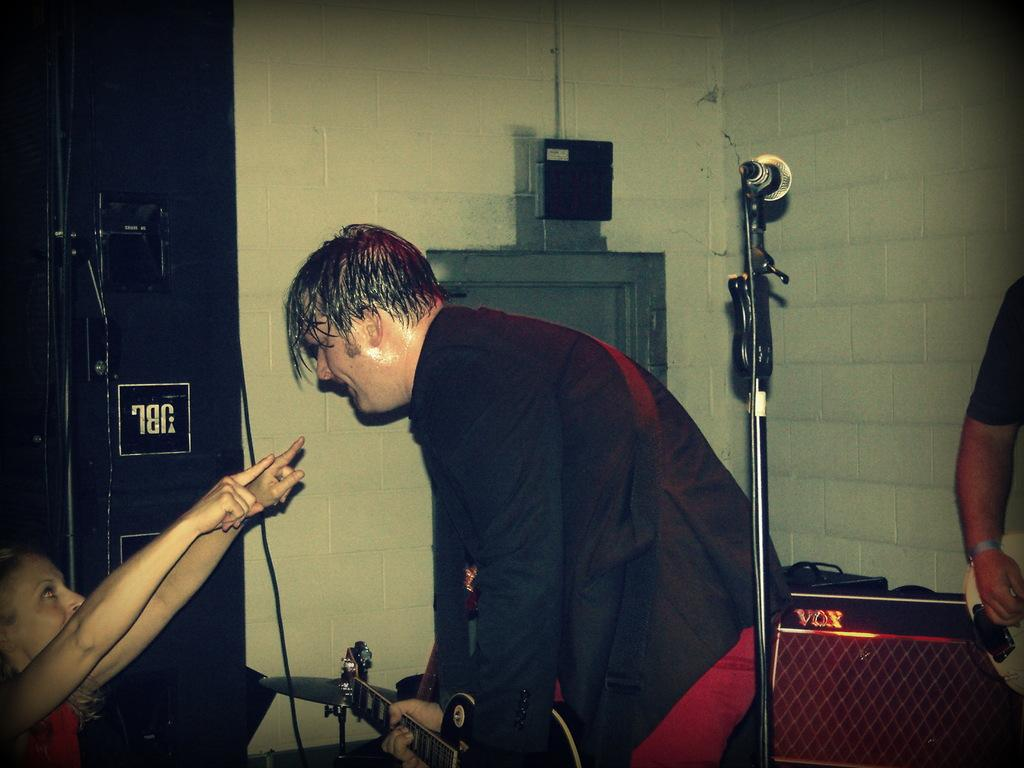What is the man in the image doing? The man is playing a guitar in the image. What object is beside the man? There is a speaker beside the man. What object is behind the man? There is a microphone behind the man. Who is in front of the man? There is a kid in front of the man. What type of stem is being used by the man to play the guitar in the image? The man is playing the guitar with his fingers, not a stem. There is no stem present in the image. 